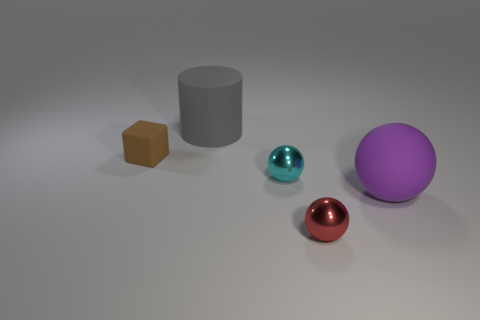What is the size of the metal ball that is to the right of the small cyan shiny thing?
Offer a very short reply. Small. What is the size of the other sphere that is the same material as the tiny red ball?
Your answer should be very brief. Small. Is the number of small red things less than the number of things?
Give a very brief answer. Yes. What is the material of the red ball that is the same size as the brown matte block?
Give a very brief answer. Metal. Are there more small brown blocks than brown metal objects?
Make the answer very short. Yes. How many objects are to the right of the small brown rubber thing and behind the large purple ball?
Your response must be concise. 2. Are there more small metal spheres in front of the small cyan object than large objects in front of the small red object?
Your response must be concise. Yes. There is a small sphere behind the large purple sphere; what is it made of?
Make the answer very short. Metal. Is the shape of the purple object the same as the shiny object behind the red sphere?
Make the answer very short. Yes. There is a metallic object that is behind the red object that is to the right of the small cyan metallic sphere; what number of small red metallic things are to the left of it?
Your response must be concise. 0. 